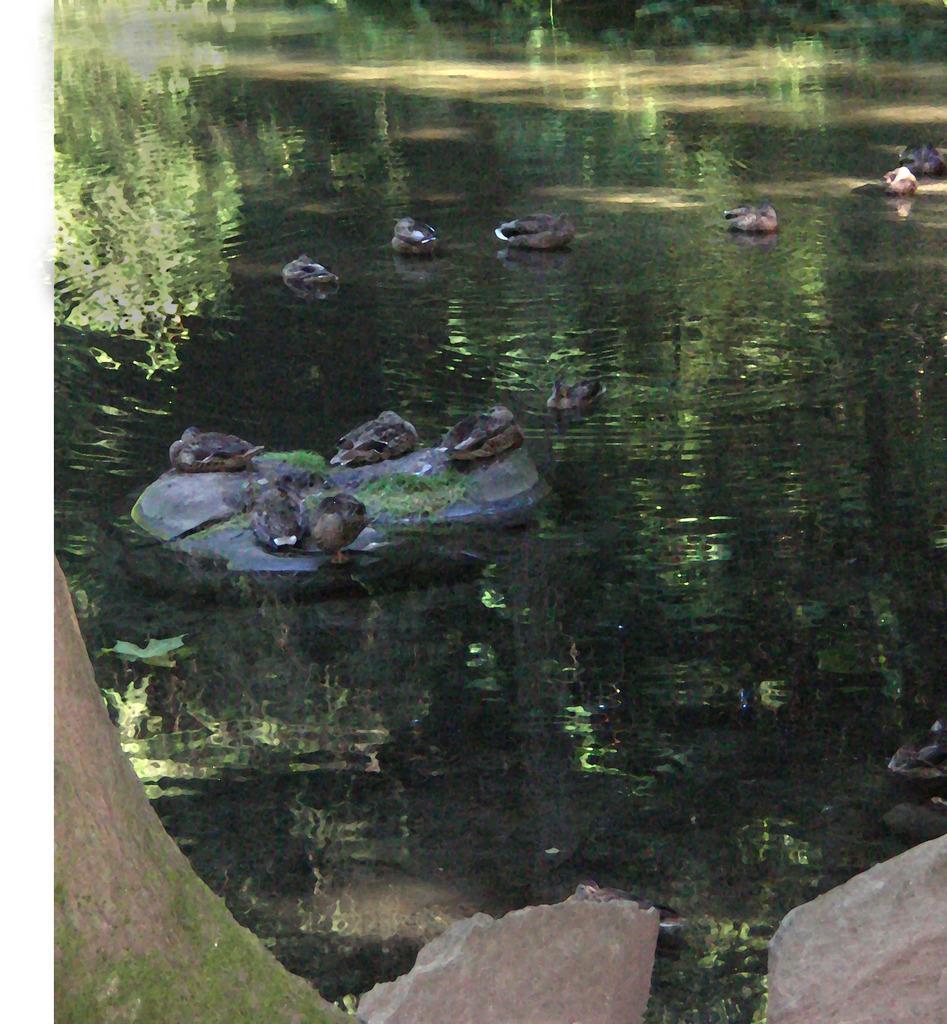How would you summarize this image in a sentence or two? In the image we can see there are ducks swimming in the water and other ducks are sitting on the rock. 